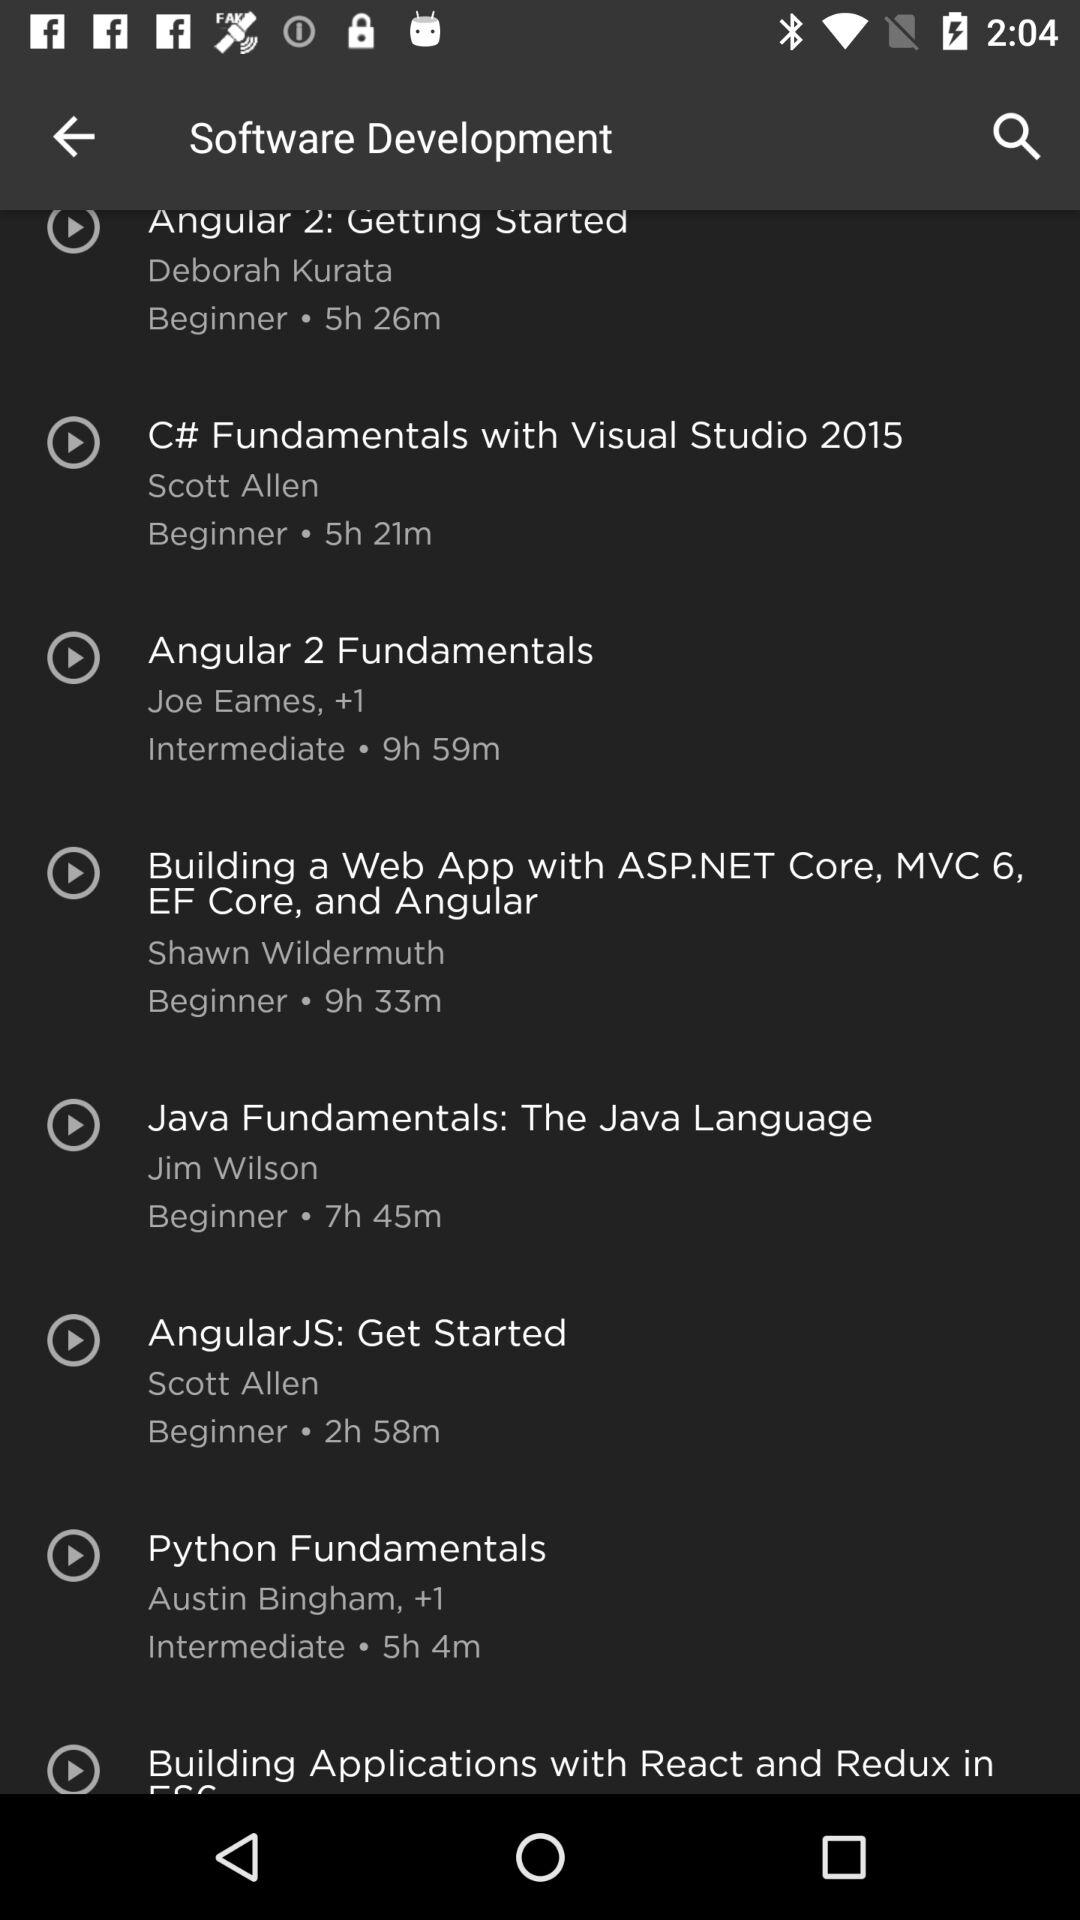Which course has the longest duration?
Answer the question using a single word or phrase. Building a Web App with ASP.NET Core, MVC 6, EF Core, and Angular 